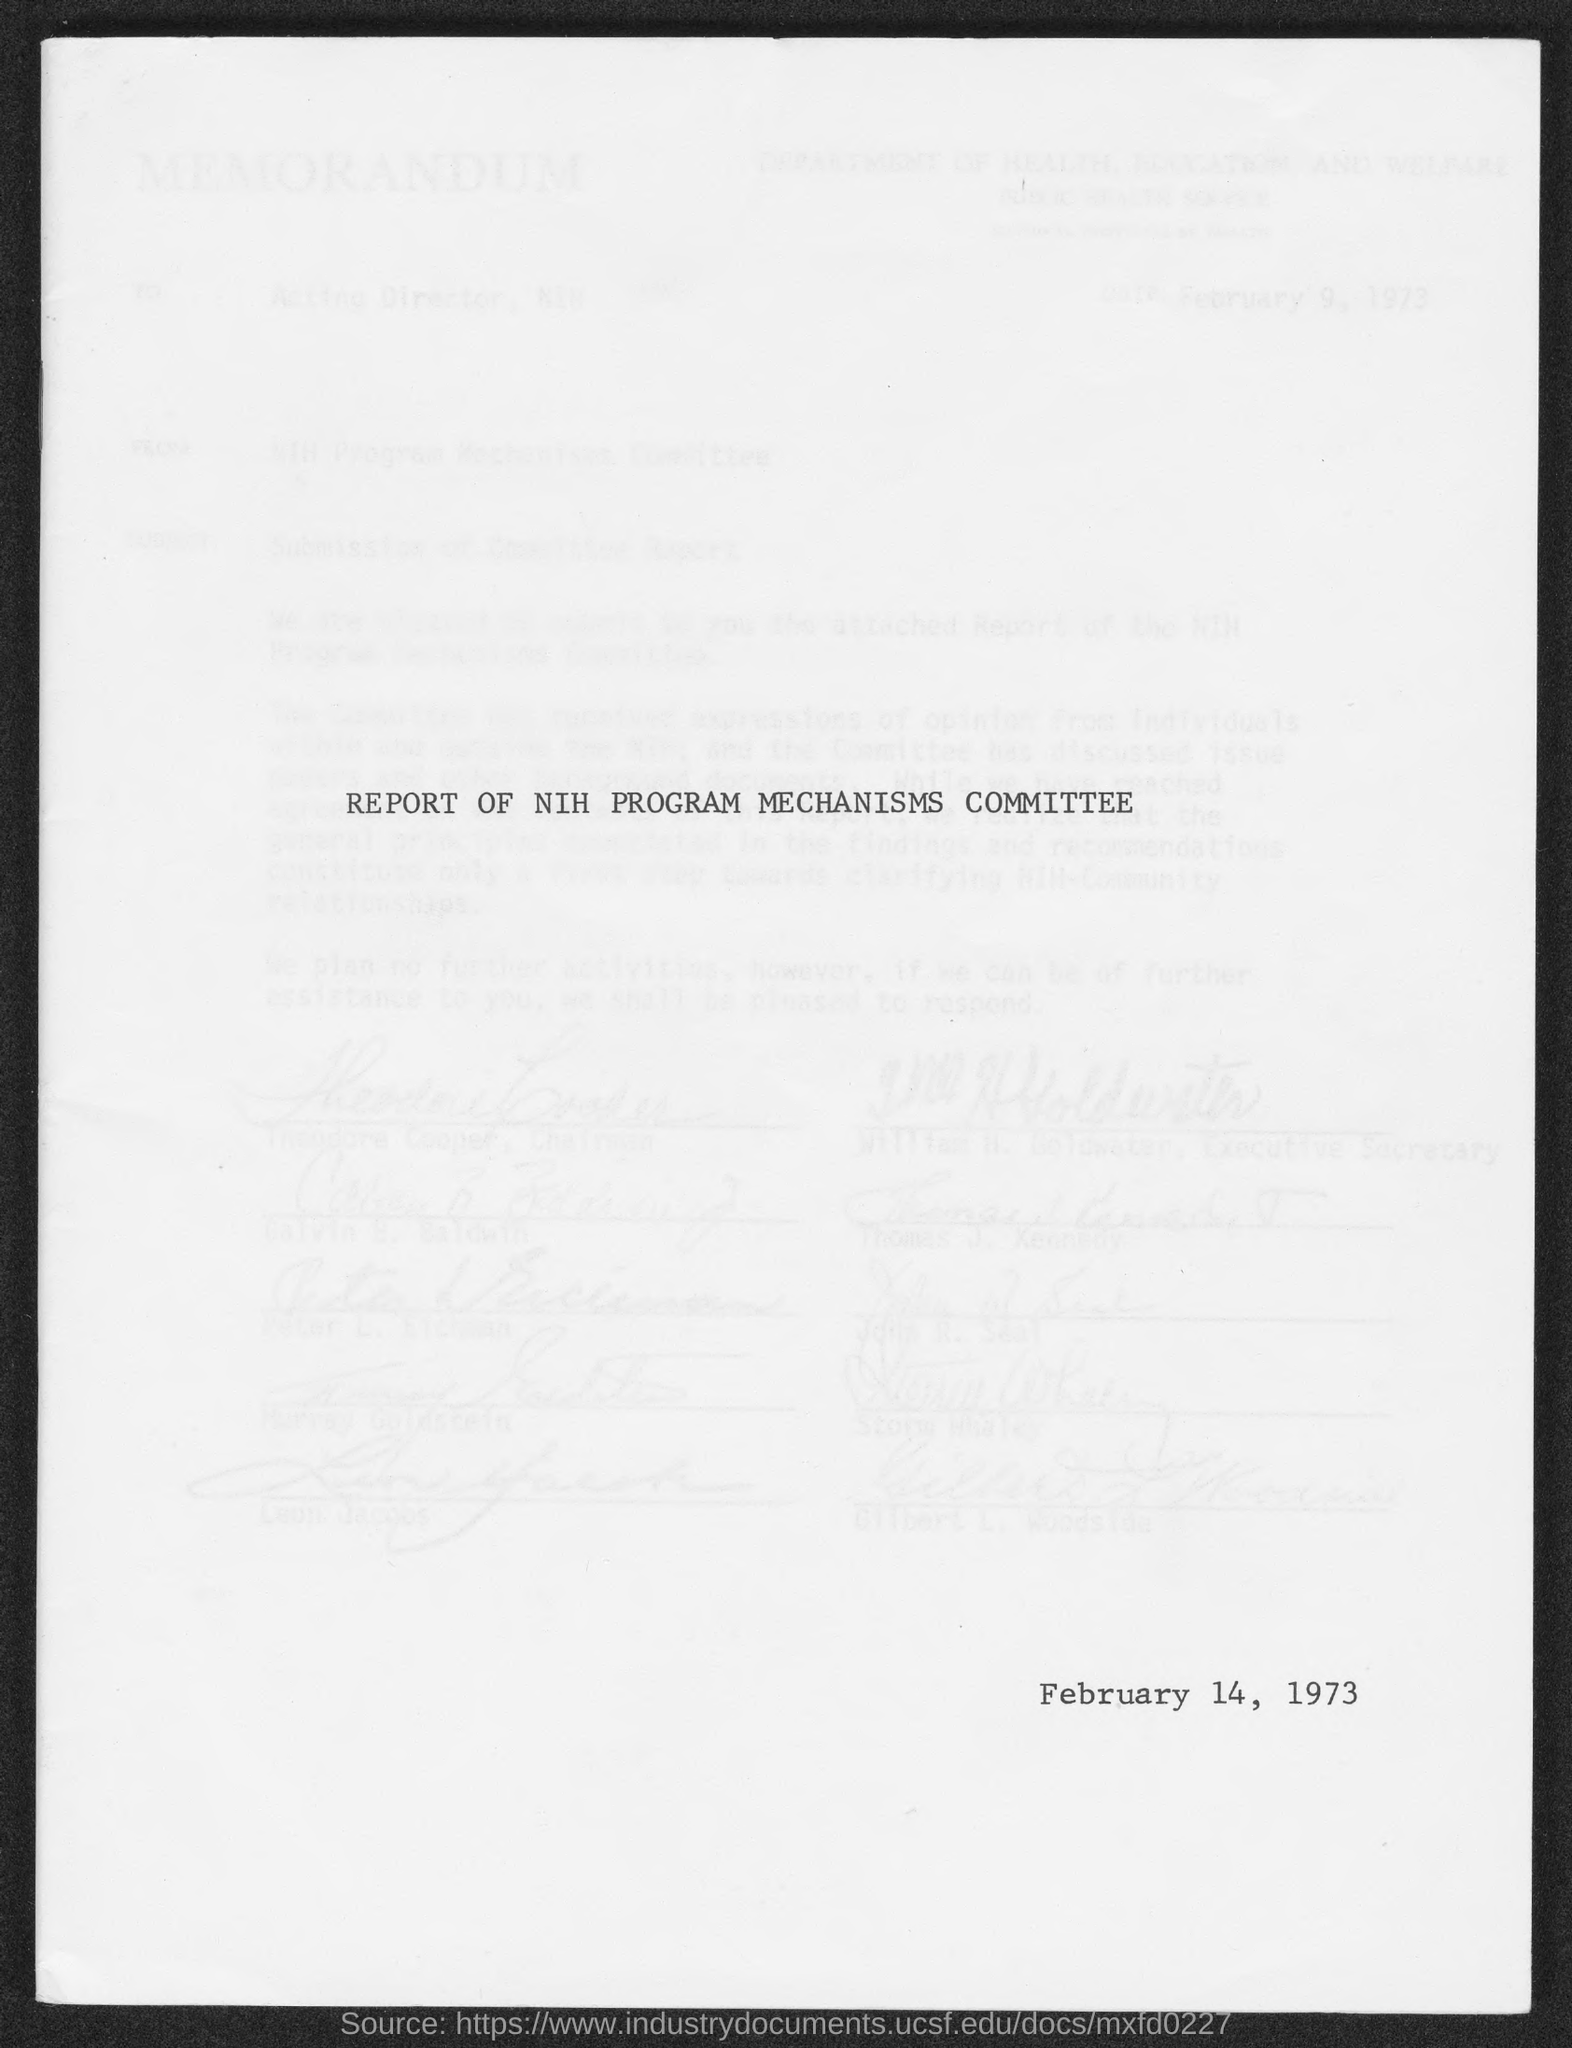Specify some key components in this picture. The date mentioned in this document is February 14, 1973. 